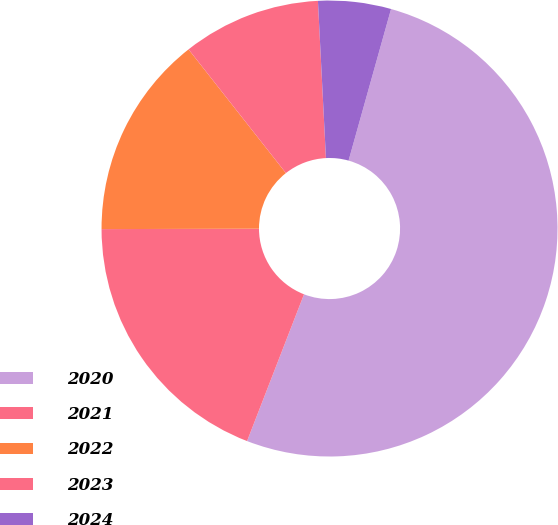<chart> <loc_0><loc_0><loc_500><loc_500><pie_chart><fcel>2020<fcel>2021<fcel>2022<fcel>2023<fcel>2024<nl><fcel>51.54%<fcel>19.07%<fcel>14.43%<fcel>9.8%<fcel>5.16%<nl></chart> 